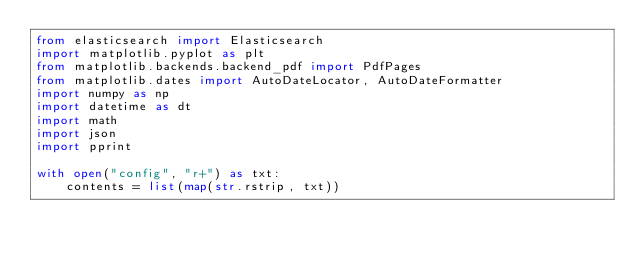Convert code to text. <code><loc_0><loc_0><loc_500><loc_500><_Python_>from elasticsearch import Elasticsearch
import matplotlib.pyplot as plt
from matplotlib.backends.backend_pdf import PdfPages
from matplotlib.dates import AutoDateLocator, AutoDateFormatter
import numpy as np
import datetime as dt
import math
import json
import pprint

with open("config", "r+") as txt:
    contents = list(map(str.rstrip, txt))
</code> 